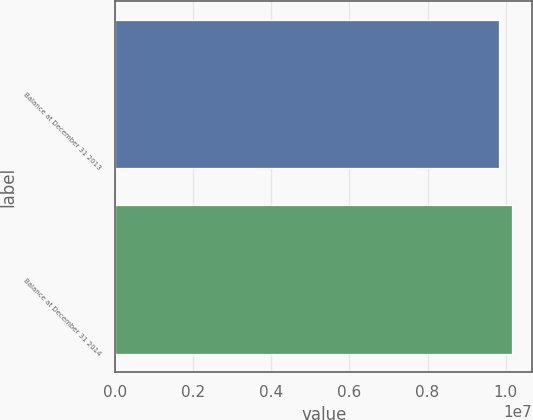Convert chart to OTSL. <chart><loc_0><loc_0><loc_500><loc_500><bar_chart><fcel>Balance at December 31 2013<fcel>Balance at December 31 2014<nl><fcel>9.82505e+06<fcel>1.01697e+07<nl></chart> 